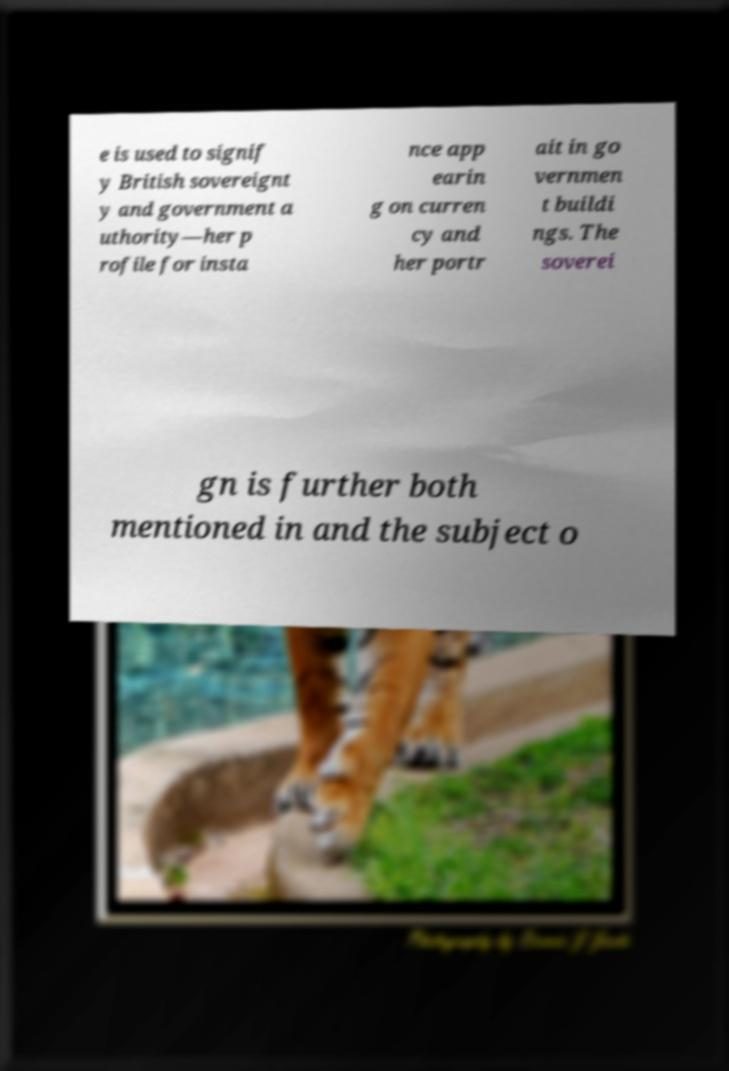Could you assist in decoding the text presented in this image and type it out clearly? e is used to signif y British sovereignt y and government a uthority—her p rofile for insta nce app earin g on curren cy and her portr ait in go vernmen t buildi ngs. The soverei gn is further both mentioned in and the subject o 